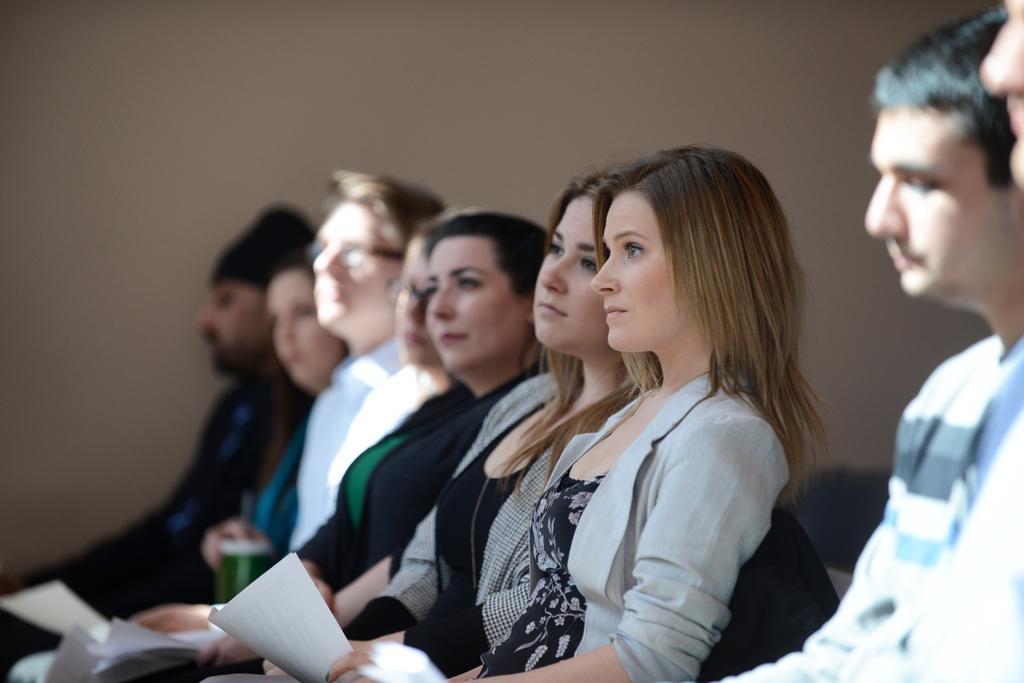Describe this image in one or two sentences. In the image we can see there are many people wearing clothes and they are sitting. This is a paper and an object. 